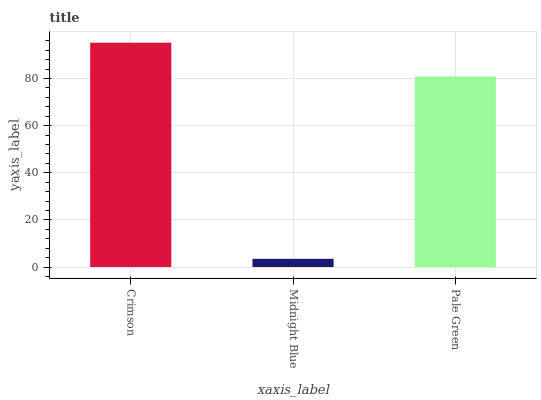Is Midnight Blue the minimum?
Answer yes or no. Yes. Is Crimson the maximum?
Answer yes or no. Yes. Is Pale Green the minimum?
Answer yes or no. No. Is Pale Green the maximum?
Answer yes or no. No. Is Pale Green greater than Midnight Blue?
Answer yes or no. Yes. Is Midnight Blue less than Pale Green?
Answer yes or no. Yes. Is Midnight Blue greater than Pale Green?
Answer yes or no. No. Is Pale Green less than Midnight Blue?
Answer yes or no. No. Is Pale Green the high median?
Answer yes or no. Yes. Is Pale Green the low median?
Answer yes or no. Yes. Is Midnight Blue the high median?
Answer yes or no. No. Is Midnight Blue the low median?
Answer yes or no. No. 